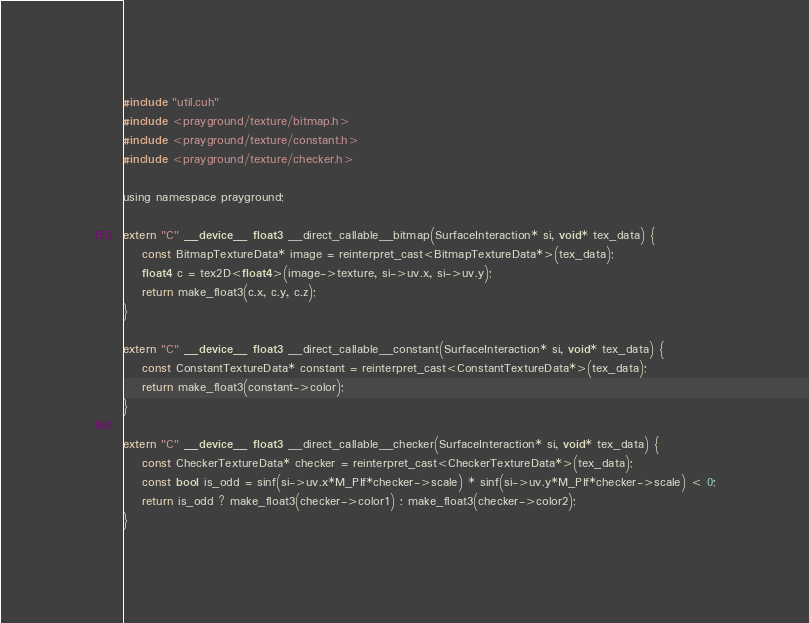<code> <loc_0><loc_0><loc_500><loc_500><_Cuda_>#include "util.cuh"
#include <prayground/texture/bitmap.h>
#include <prayground/texture/constant.h>
#include <prayground/texture/checker.h>

using namespace prayground;

extern "C" __device__ float3 __direct_callable__bitmap(SurfaceInteraction* si, void* tex_data) {
    const BitmapTextureData* image = reinterpret_cast<BitmapTextureData*>(tex_data);
    float4 c = tex2D<float4>(image->texture, si->uv.x, si->uv.y);
    return make_float3(c.x, c.y, c.z);
}

extern "C" __device__ float3 __direct_callable__constant(SurfaceInteraction* si, void* tex_data) {
    const ConstantTextureData* constant = reinterpret_cast<ConstantTextureData*>(tex_data);
    return make_float3(constant->color);
}

extern "C" __device__ float3 __direct_callable__checker(SurfaceInteraction* si, void* tex_data) {
    const CheckerTextureData* checker = reinterpret_cast<CheckerTextureData*>(tex_data);
    const bool is_odd = sinf(si->uv.x*M_PIf*checker->scale) * sinf(si->uv.y*M_PIf*checker->scale) < 0;
    return is_odd ? make_float3(checker->color1) : make_float3(checker->color2);
}</code> 